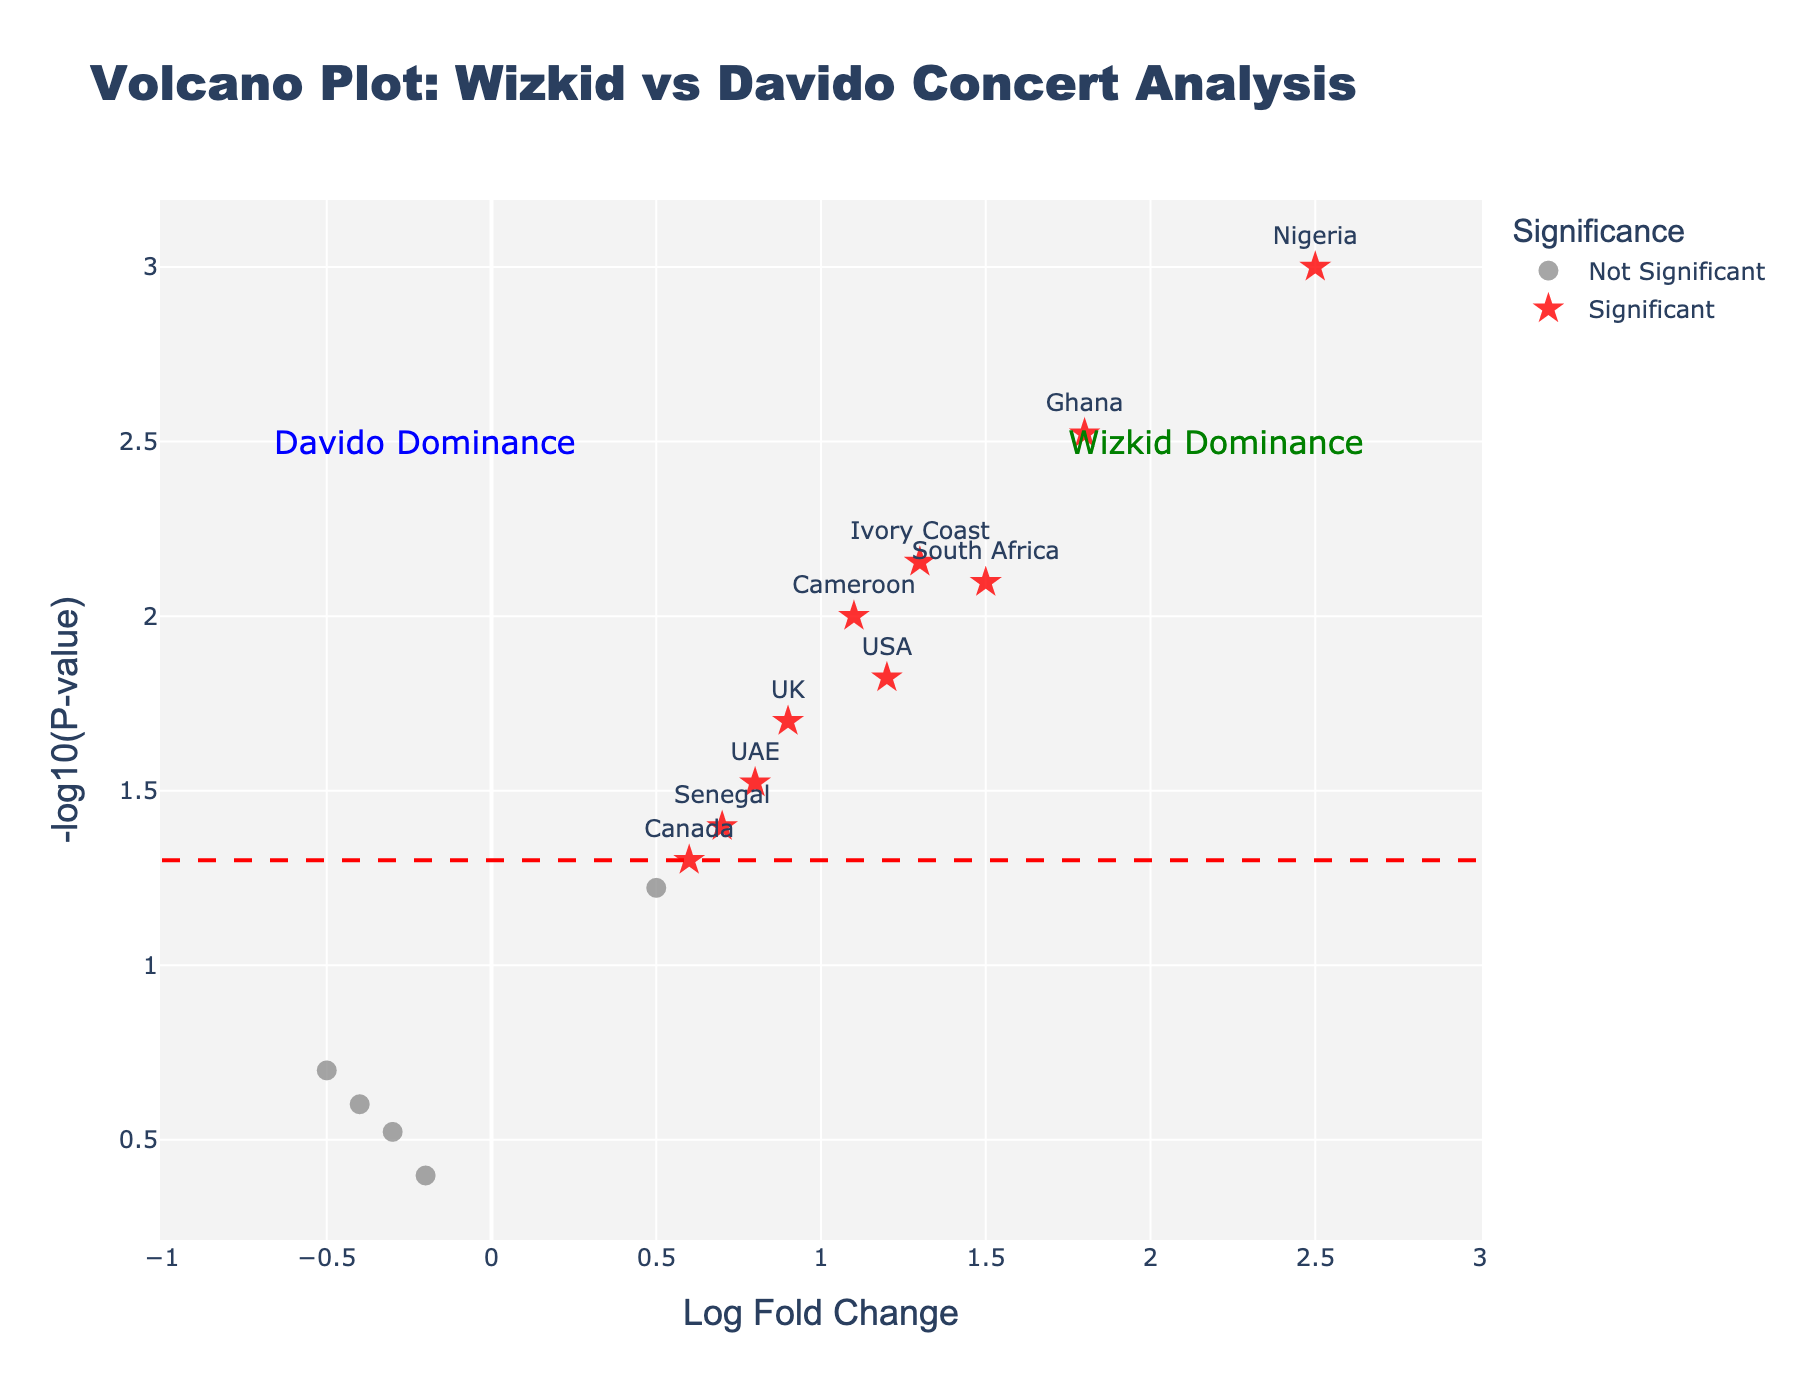Which country has the highest log fold change? The country with the highest log fold change value is at the farthest right point on the x-axis. Nigeria has a log fold change of 2.5, which is the highest.
Answer: Nigeria How many significant countries are labeled as significant on the plot? Significant countries are represented by red star symbols on the plot. Counting all red stars, there are 11 significant countries.
Answer: 11 What is the log fold change of the UK, and is it significant? The UK is plotted with a log fold change of 0.9, and it is among the red star symbols, indicating it is significant.
Answer: 0.9, Yes Which country has the lowest p-value among the significant ones? The country with the lowest p-value will have the highest -log10(p-value) on the y-axis. Nigeria has the highest value on the y-axis, corresponding to the lowest p-value (0.001).
Answer: Nigeria Compare the log fold changes between USA and South Africa. Which one is higher? The USA has a log fold change of 1.2 while South Africa has a log fold change of 1.5. Therefore, South Africa has a higher log fold change.
Answer: South Africa How many countries have a negative log fold change, and are any of them significant? The countries with negative log fold change values are to the left of the zero mark on the x-axis. Kenya, France, Tanzania, and Uganda have negative log fold changes. None of these points are represented by red stars, indicating none are significant.
Answer: 4, None What's the significance threshold for p-value in the plot? The significance threshold line for the p-value is represented by a horizontal dashed red line on the plot. This line corresponds to -log10(0.05), which is approximately 1.3.
Answer: 0.05 What annotation is used to indicate Wizkid's dominance, and where is it located? The annotation "Wizkid Dominance" is placed near the top right of the plot, where log fold changes are high and p-values are low.
Answer: 'Wizkid Dominance', top right In the context of this plot, what does a red star symbol represent? A red star symbol represents countries with significant log fold changes and p-values below the threshold (0.05).
Answer: Significant countries 